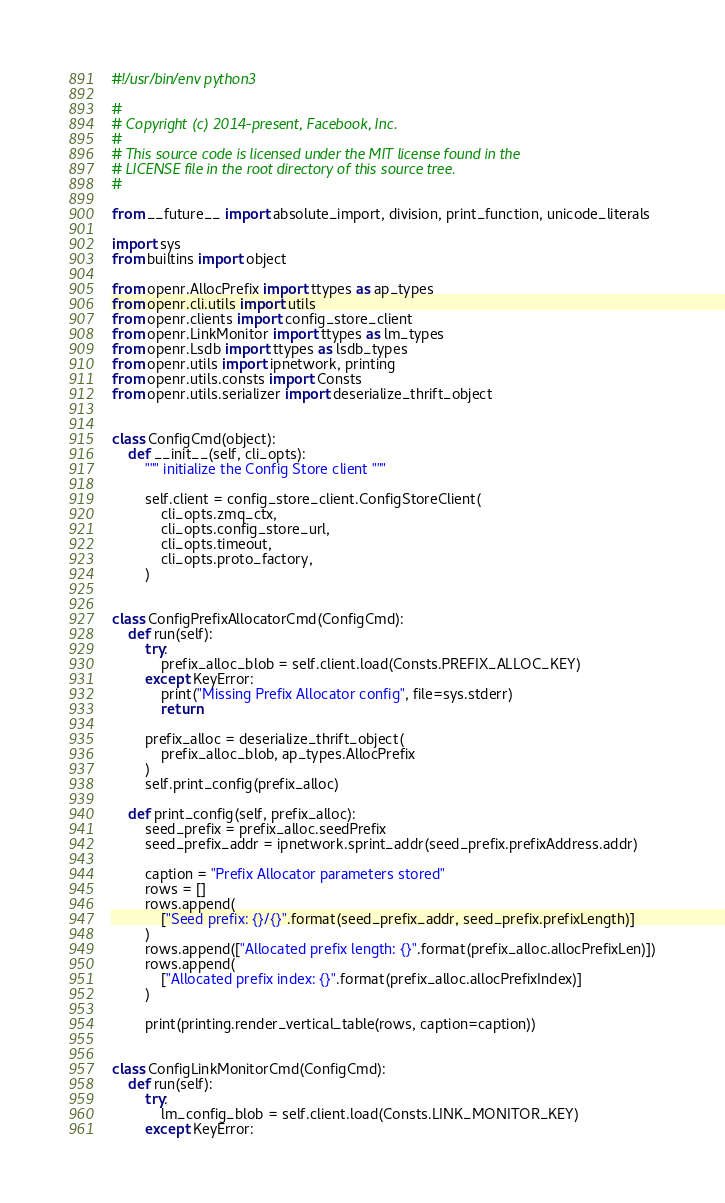Convert code to text. <code><loc_0><loc_0><loc_500><loc_500><_Python_>#!/usr/bin/env python3

#
# Copyright (c) 2014-present, Facebook, Inc.
#
# This source code is licensed under the MIT license found in the
# LICENSE file in the root directory of this source tree.
#

from __future__ import absolute_import, division, print_function, unicode_literals

import sys
from builtins import object

from openr.AllocPrefix import ttypes as ap_types
from openr.cli.utils import utils
from openr.clients import config_store_client
from openr.LinkMonitor import ttypes as lm_types
from openr.Lsdb import ttypes as lsdb_types
from openr.utils import ipnetwork, printing
from openr.utils.consts import Consts
from openr.utils.serializer import deserialize_thrift_object


class ConfigCmd(object):
    def __init__(self, cli_opts):
        """ initialize the Config Store client """

        self.client = config_store_client.ConfigStoreClient(
            cli_opts.zmq_ctx,
            cli_opts.config_store_url,
            cli_opts.timeout,
            cli_opts.proto_factory,
        )


class ConfigPrefixAllocatorCmd(ConfigCmd):
    def run(self):
        try:
            prefix_alloc_blob = self.client.load(Consts.PREFIX_ALLOC_KEY)
        except KeyError:
            print("Missing Prefix Allocator config", file=sys.stderr)
            return

        prefix_alloc = deserialize_thrift_object(
            prefix_alloc_blob, ap_types.AllocPrefix
        )
        self.print_config(prefix_alloc)

    def print_config(self, prefix_alloc):
        seed_prefix = prefix_alloc.seedPrefix
        seed_prefix_addr = ipnetwork.sprint_addr(seed_prefix.prefixAddress.addr)

        caption = "Prefix Allocator parameters stored"
        rows = []
        rows.append(
            ["Seed prefix: {}/{}".format(seed_prefix_addr, seed_prefix.prefixLength)]
        )
        rows.append(["Allocated prefix length: {}".format(prefix_alloc.allocPrefixLen)])
        rows.append(
            ["Allocated prefix index: {}".format(prefix_alloc.allocPrefixIndex)]
        )

        print(printing.render_vertical_table(rows, caption=caption))


class ConfigLinkMonitorCmd(ConfigCmd):
    def run(self):
        try:
            lm_config_blob = self.client.load(Consts.LINK_MONITOR_KEY)
        except KeyError:</code> 